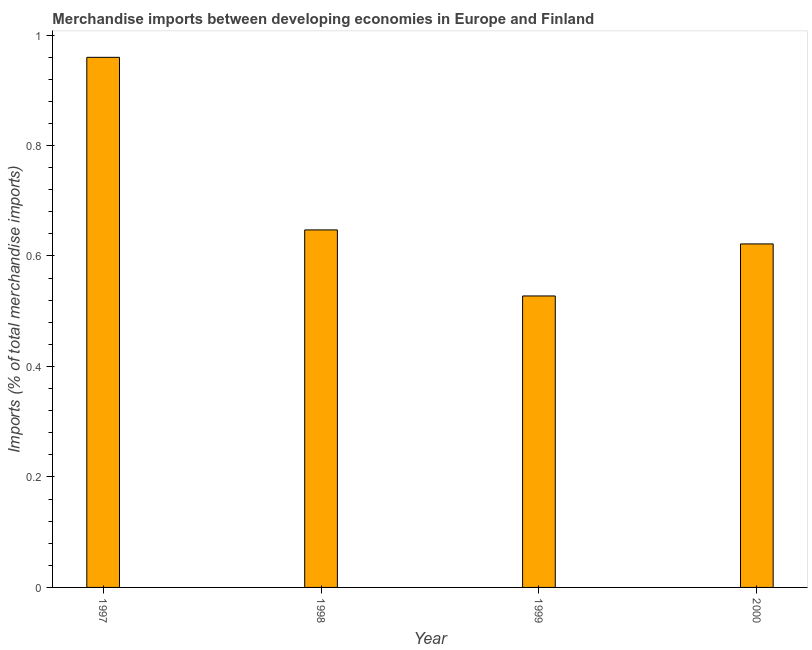Does the graph contain any zero values?
Ensure brevity in your answer.  No. Does the graph contain grids?
Offer a very short reply. No. What is the title of the graph?
Your answer should be compact. Merchandise imports between developing economies in Europe and Finland. What is the label or title of the X-axis?
Provide a succinct answer. Year. What is the label or title of the Y-axis?
Make the answer very short. Imports (% of total merchandise imports). What is the merchandise imports in 2000?
Keep it short and to the point. 0.62. Across all years, what is the maximum merchandise imports?
Keep it short and to the point. 0.96. Across all years, what is the minimum merchandise imports?
Offer a terse response. 0.53. What is the sum of the merchandise imports?
Ensure brevity in your answer.  2.76. What is the difference between the merchandise imports in 1999 and 2000?
Your response must be concise. -0.09. What is the average merchandise imports per year?
Ensure brevity in your answer.  0.69. What is the median merchandise imports?
Provide a succinct answer. 0.63. In how many years, is the merchandise imports greater than 0.8 %?
Your answer should be compact. 1. Do a majority of the years between 1999 and 1997 (inclusive) have merchandise imports greater than 0.76 %?
Your answer should be compact. Yes. What is the ratio of the merchandise imports in 1997 to that in 1998?
Keep it short and to the point. 1.48. Is the merchandise imports in 1997 less than that in 1999?
Offer a terse response. No. Is the difference between the merchandise imports in 1997 and 1998 greater than the difference between any two years?
Give a very brief answer. No. What is the difference between the highest and the second highest merchandise imports?
Offer a terse response. 0.31. What is the difference between the highest and the lowest merchandise imports?
Offer a very short reply. 0.43. In how many years, is the merchandise imports greater than the average merchandise imports taken over all years?
Offer a terse response. 1. Are all the bars in the graph horizontal?
Make the answer very short. No. How many years are there in the graph?
Give a very brief answer. 4. Are the values on the major ticks of Y-axis written in scientific E-notation?
Offer a very short reply. No. What is the Imports (% of total merchandise imports) in 1997?
Your answer should be very brief. 0.96. What is the Imports (% of total merchandise imports) of 1998?
Your answer should be very brief. 0.65. What is the Imports (% of total merchandise imports) in 1999?
Keep it short and to the point. 0.53. What is the Imports (% of total merchandise imports) of 2000?
Give a very brief answer. 0.62. What is the difference between the Imports (% of total merchandise imports) in 1997 and 1998?
Your answer should be compact. 0.31. What is the difference between the Imports (% of total merchandise imports) in 1997 and 1999?
Give a very brief answer. 0.43. What is the difference between the Imports (% of total merchandise imports) in 1997 and 2000?
Make the answer very short. 0.34. What is the difference between the Imports (% of total merchandise imports) in 1998 and 1999?
Give a very brief answer. 0.12. What is the difference between the Imports (% of total merchandise imports) in 1998 and 2000?
Give a very brief answer. 0.03. What is the difference between the Imports (% of total merchandise imports) in 1999 and 2000?
Give a very brief answer. -0.09. What is the ratio of the Imports (% of total merchandise imports) in 1997 to that in 1998?
Make the answer very short. 1.48. What is the ratio of the Imports (% of total merchandise imports) in 1997 to that in 1999?
Provide a succinct answer. 1.82. What is the ratio of the Imports (% of total merchandise imports) in 1997 to that in 2000?
Ensure brevity in your answer.  1.54. What is the ratio of the Imports (% of total merchandise imports) in 1998 to that in 1999?
Your answer should be compact. 1.23. What is the ratio of the Imports (% of total merchandise imports) in 1998 to that in 2000?
Keep it short and to the point. 1.04. What is the ratio of the Imports (% of total merchandise imports) in 1999 to that in 2000?
Your answer should be compact. 0.85. 